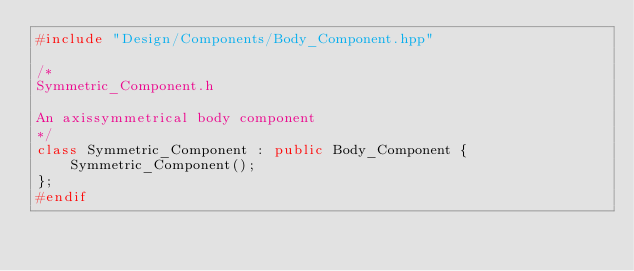<code> <loc_0><loc_0><loc_500><loc_500><_C++_>#include "Design/Components/Body_Component.hpp"

/*
Symmetric_Component.h

An axissymmetrical body component
*/
class Symmetric_Component : public Body_Component {
    Symmetric_Component();
};
#endif</code> 